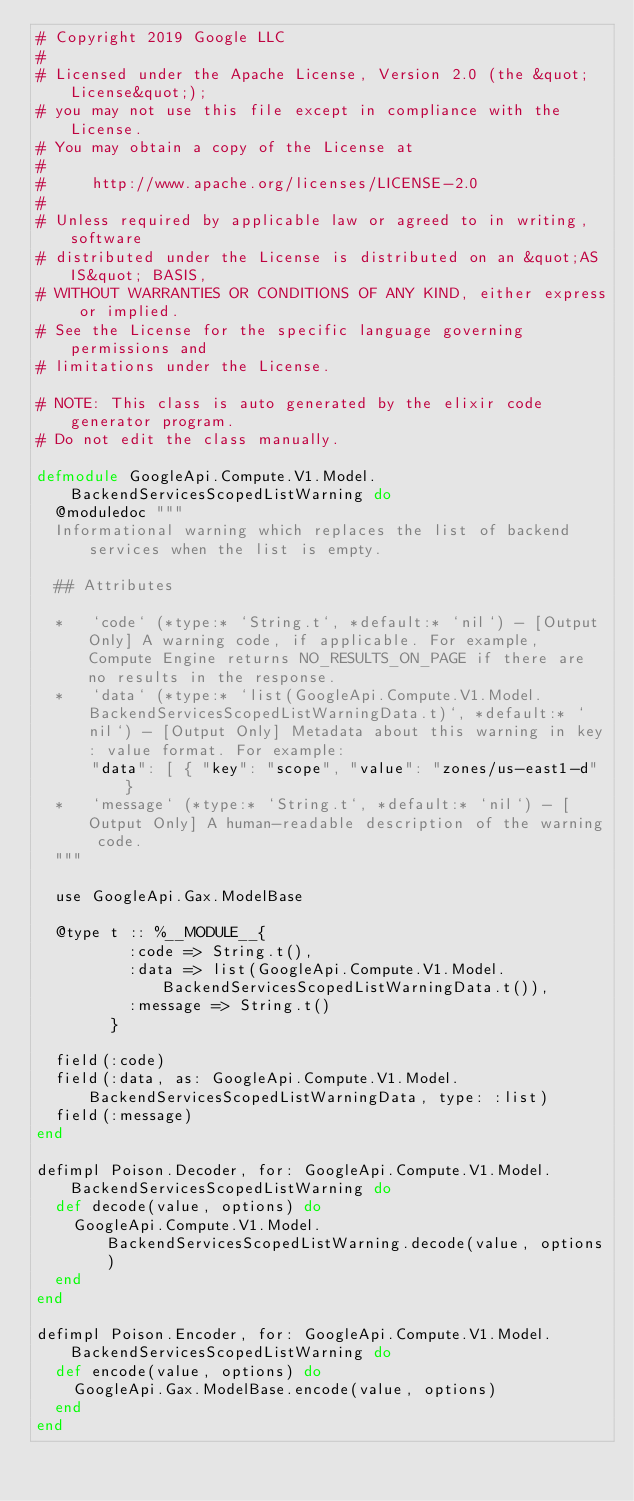Convert code to text. <code><loc_0><loc_0><loc_500><loc_500><_Elixir_># Copyright 2019 Google LLC
#
# Licensed under the Apache License, Version 2.0 (the &quot;License&quot;);
# you may not use this file except in compliance with the License.
# You may obtain a copy of the License at
#
#     http://www.apache.org/licenses/LICENSE-2.0
#
# Unless required by applicable law or agreed to in writing, software
# distributed under the License is distributed on an &quot;AS IS&quot; BASIS,
# WITHOUT WARRANTIES OR CONDITIONS OF ANY KIND, either express or implied.
# See the License for the specific language governing permissions and
# limitations under the License.

# NOTE: This class is auto generated by the elixir code generator program.
# Do not edit the class manually.

defmodule GoogleApi.Compute.V1.Model.BackendServicesScopedListWarning do
  @moduledoc """
  Informational warning which replaces the list of backend services when the list is empty.

  ## Attributes

  *   `code` (*type:* `String.t`, *default:* `nil`) - [Output Only] A warning code, if applicable. For example, Compute Engine returns NO_RESULTS_ON_PAGE if there are no results in the response.
  *   `data` (*type:* `list(GoogleApi.Compute.V1.Model.BackendServicesScopedListWarningData.t)`, *default:* `nil`) - [Output Only] Metadata about this warning in key: value format. For example:
      "data": [ { "key": "scope", "value": "zones/us-east1-d" }
  *   `message` (*type:* `String.t`, *default:* `nil`) - [Output Only] A human-readable description of the warning code.
  """

  use GoogleApi.Gax.ModelBase

  @type t :: %__MODULE__{
          :code => String.t(),
          :data => list(GoogleApi.Compute.V1.Model.BackendServicesScopedListWarningData.t()),
          :message => String.t()
        }

  field(:code)
  field(:data, as: GoogleApi.Compute.V1.Model.BackendServicesScopedListWarningData, type: :list)
  field(:message)
end

defimpl Poison.Decoder, for: GoogleApi.Compute.V1.Model.BackendServicesScopedListWarning do
  def decode(value, options) do
    GoogleApi.Compute.V1.Model.BackendServicesScopedListWarning.decode(value, options)
  end
end

defimpl Poison.Encoder, for: GoogleApi.Compute.V1.Model.BackendServicesScopedListWarning do
  def encode(value, options) do
    GoogleApi.Gax.ModelBase.encode(value, options)
  end
end
</code> 